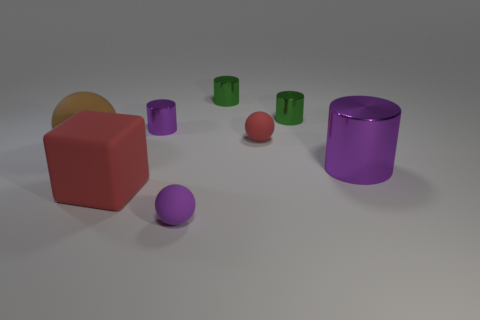Subtract all big cylinders. How many cylinders are left? 3 Subtract all purple cylinders. How many cylinders are left? 2 Subtract all yellow balls. How many purple cylinders are left? 2 Subtract 1 balls. How many balls are left? 2 Add 1 large green matte blocks. How many objects exist? 9 Subtract all balls. How many objects are left? 5 Subtract all red cylinders. Subtract all green blocks. How many cylinders are left? 4 Subtract 0 cyan cubes. How many objects are left? 8 Subtract all big red cubes. Subtract all big red matte blocks. How many objects are left? 6 Add 2 large red rubber cubes. How many large red rubber cubes are left? 3 